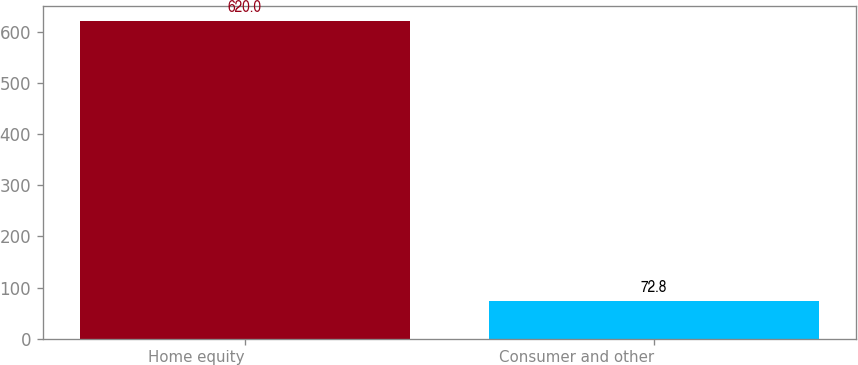Convert chart. <chart><loc_0><loc_0><loc_500><loc_500><bar_chart><fcel>Home equity<fcel>Consumer and other<nl><fcel>620<fcel>72.8<nl></chart> 